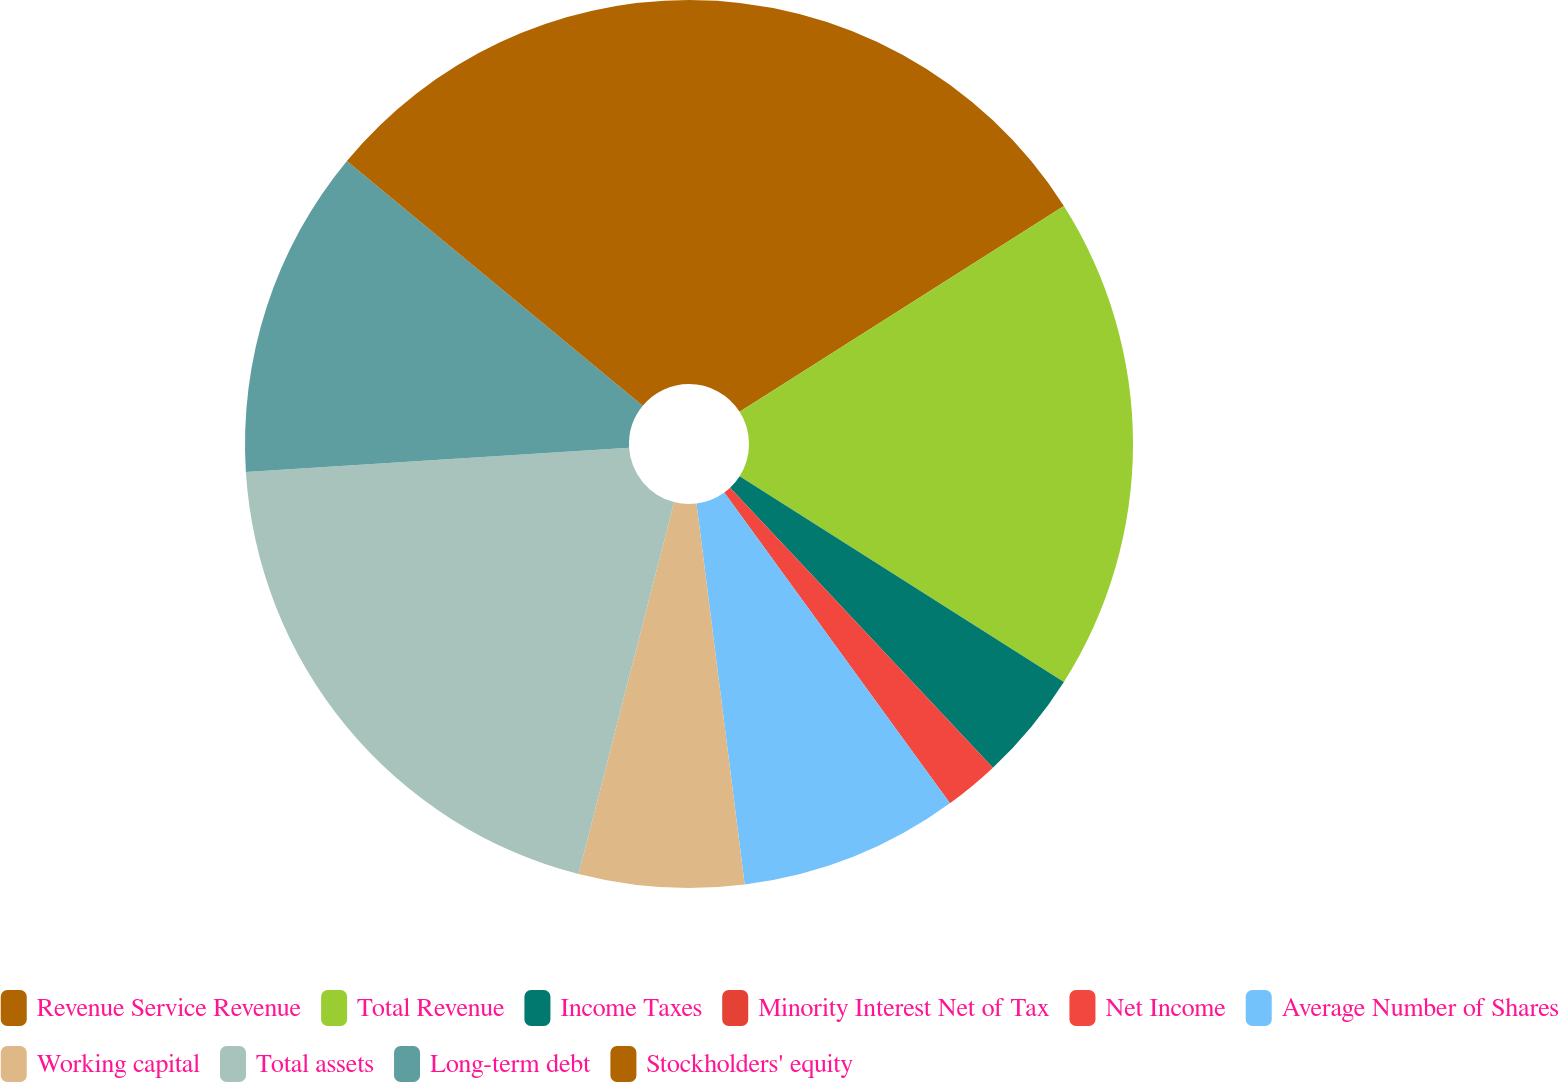<chart> <loc_0><loc_0><loc_500><loc_500><pie_chart><fcel>Revenue Service Revenue<fcel>Total Revenue<fcel>Income Taxes<fcel>Minority Interest Net of Tax<fcel>Net Income<fcel>Average Number of Shares<fcel>Working capital<fcel>Total assets<fcel>Long-term debt<fcel>Stockholders' equity<nl><fcel>16.0%<fcel>18.0%<fcel>4.0%<fcel>0.0%<fcel>2.0%<fcel>8.0%<fcel>6.0%<fcel>20.0%<fcel>12.0%<fcel>14.0%<nl></chart> 